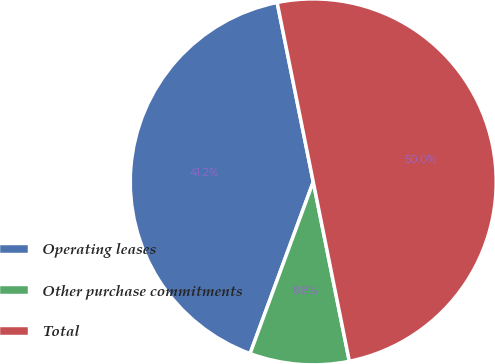Convert chart to OTSL. <chart><loc_0><loc_0><loc_500><loc_500><pie_chart><fcel>Operating leases<fcel>Other purchase commitments<fcel>Total<nl><fcel>41.23%<fcel>8.77%<fcel>50.0%<nl></chart> 